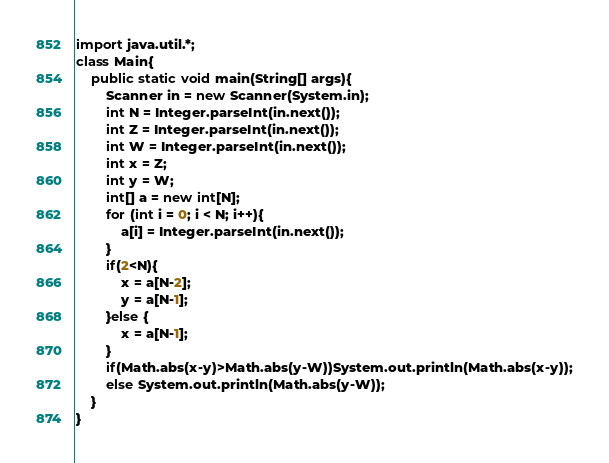<code> <loc_0><loc_0><loc_500><loc_500><_Java_>import java.util.*;
class Main{
	public static void main(String[] args){
		Scanner in = new Scanner(System.in);
		int N = Integer.parseInt(in.next());
		int Z = Integer.parseInt(in.next());
		int W = Integer.parseInt(in.next());
		int x = Z;
		int y = W;
		int[] a = new int[N];
		for (int i = 0; i < N; i++){
			a[i] = Integer.parseInt(in.next());
		}
		if(2<N){
			x = a[N-2];
			y = a[N-1];
		}else {
			x = a[N-1];
		}
		if(Math.abs(x-y)>Math.abs(y-W))System.out.println(Math.abs(x-y));
		else System.out.println(Math.abs(y-W));
	}
}</code> 